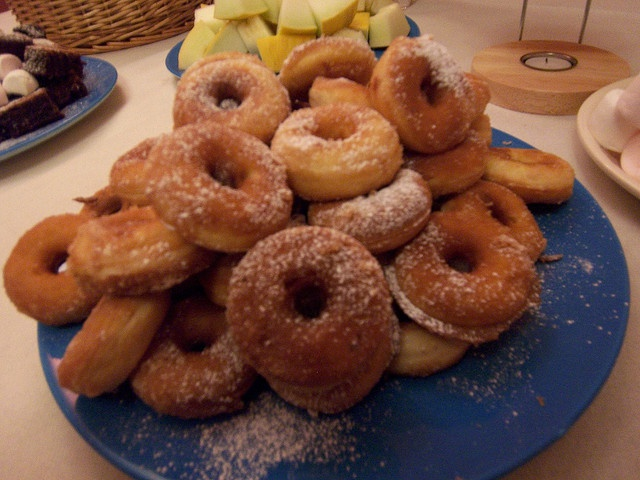Describe the objects in this image and their specific colors. I can see dining table in maroon, black, and brown tones, donut in maroon, brown, black, and tan tones, donut in maroon, brown, and black tones, donut in maroon, brown, salmon, and tan tones, and donut in maroon and brown tones in this image. 